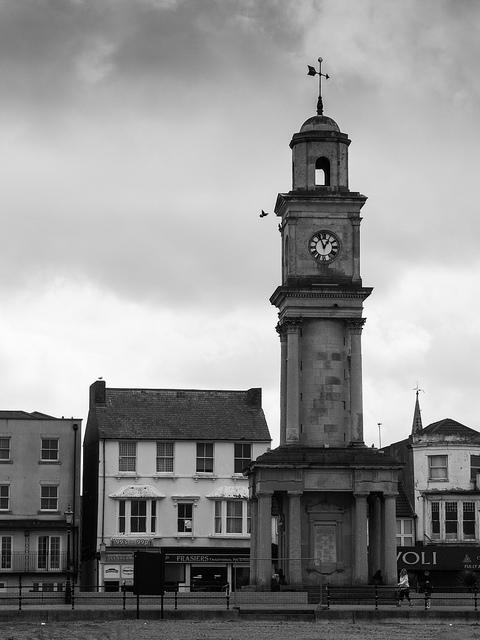What is the name for the cross shaped structure on top of the tower? Please explain your reasoning. weather vane. The name is a weather vane. 